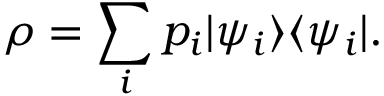Convert formula to latex. <formula><loc_0><loc_0><loc_500><loc_500>\rho = \sum _ { i } p _ { i } | \psi _ { i } \rangle \langle \psi _ { i } | .</formula> 